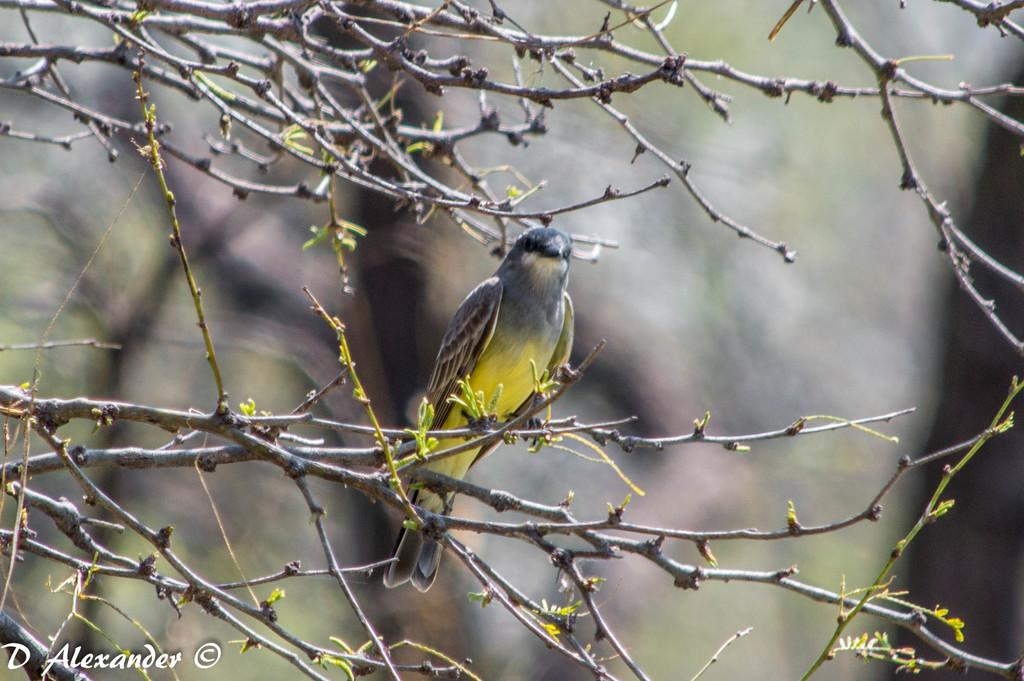What type of animal can be seen in the image? There is a bird in the image. Where is the bird located? The bird is standing on a branch. What is the condition of the branch? The branch has leaves. How would you describe the background of the image? The background of the image is blurry. What else can be seen in the front side of the image? There are branches visible in the front side of the image. What type of wrist accessory is the bird wearing in the image? There is no wrist accessory visible on the bird in the image. What kind of bait is the bird using to catch fish in the image? There is no fishing activity or bait present in the image; it features a bird standing on a branch. 